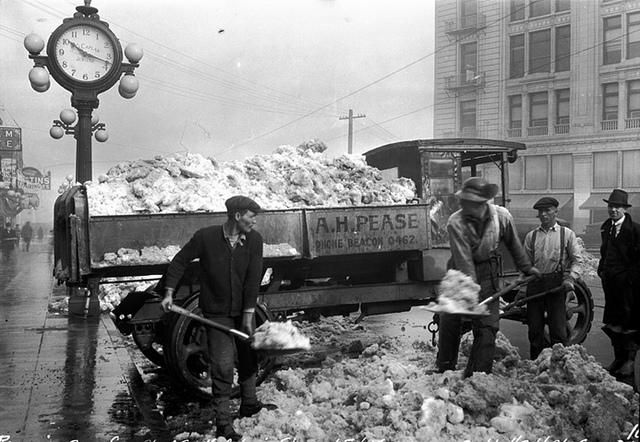What does this vehicle hold in it's rear?

Choices:
A) coal
B) wheat
C) wood
D) snow snow 